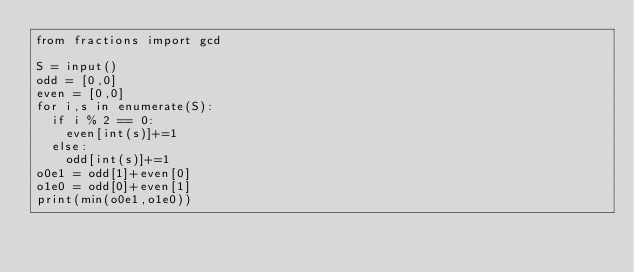Convert code to text. <code><loc_0><loc_0><loc_500><loc_500><_Python_>from fractions import gcd

S = input()
odd = [0,0]
even = [0,0]
for i,s in enumerate(S):
  if i % 2 == 0:
    even[int(s)]+=1
  else:
    odd[int(s)]+=1
o0e1 = odd[1]+even[0]
o1e0 = odd[0]+even[1]
print(min(o0e1,o1e0))
  </code> 